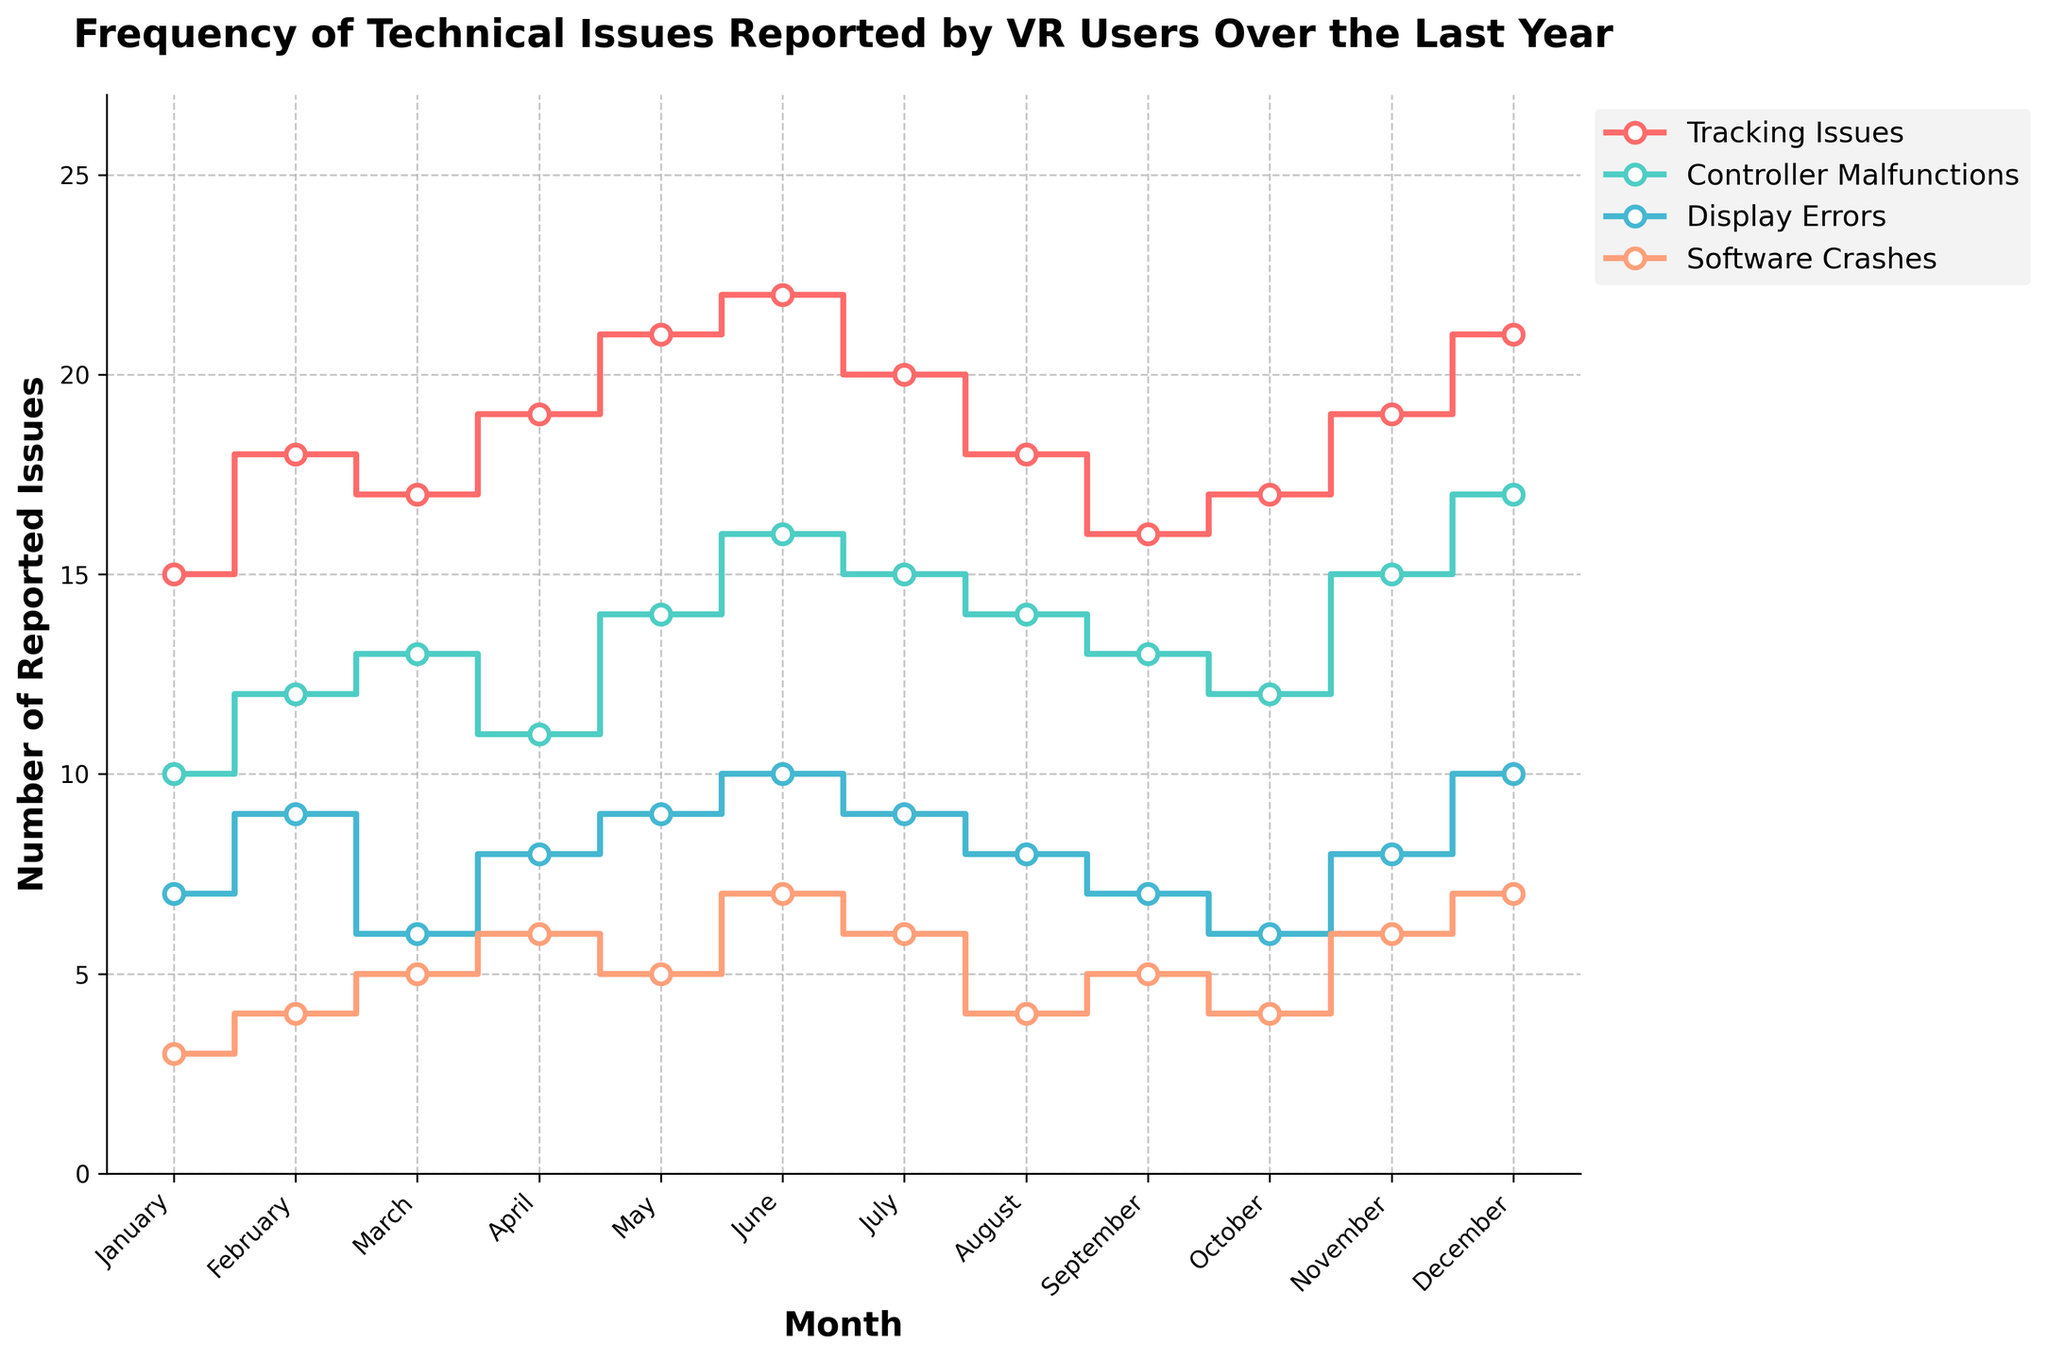What month had the highest number of Display Errors? Look at the y-axis values for Display Errors in each month, then identify the highest value. December had 10 Display Errors, which is the highest.
Answer: December How many issues were reported in March for Controller Malfunctions? Look at the y-axis values for Controller Malfunctions in March. The figure shows 13 reported issues.
Answer: 13 What is the overall trend for Tracking Issues over the year? Observe the line for Tracking Issues. The general trend is that it gradually increases from January (15 issues) to June (22 issues), then slightly fluctuates with a slight decline and rise towards December.
Answer: Gradually increasing Which month showed the lowest count of Software Crashes? Look at the y-axis values for Software Crashes across all months and identify the lowest. January had only 3 Software Crashes, which is the lowest.
Answer: January By how many issues did Controller Malfunctions increase from January to December? Identify the y-axis values for Controller Malfunctions in January (10 issues) and December (17 issues), then subtract to find the difference (17 - 10).
Answer: 7 During which month did all four types of issues have approximately similar counts? Compare the y-axis values for each type of issue across all months looking for similar values. The month of August has Tracking Issues (18), Controller Malfunctions (14), Display Errors (8), and Software Crashes (4), which are relatively more balanced compared to other months.
Answer: August Which type of issue showed the most significant increase from the beginning to the end of the year? Compare the increase in y-axis values for each type of issue from January to December. Software Crashes increased from 3 to 7, which is more than doubling.
Answer: Software Crashes What is the average number of Tracking Issues reported over the entire year? Sum the number of Tracking Issues reported each month (15+18+17+19+21+22+20+18+16+17+19+21) and divide by 12 (the number of months). 223/12 = about 18.58.
Answer: ~18.58 How did Display Errors change from February to November? Look at the y-axis values for Display Errors in February (9 issues) and November (8 issues) and compare the difference between the counts (9 - 8).
Answer: Decreased by 1 